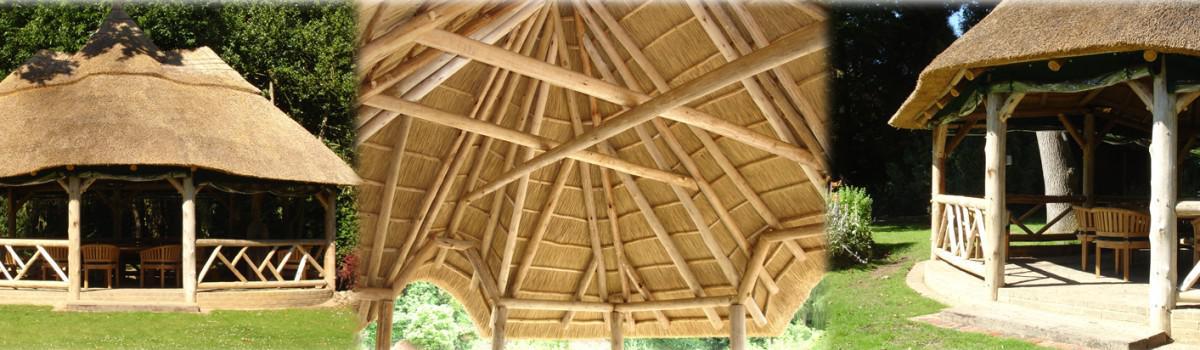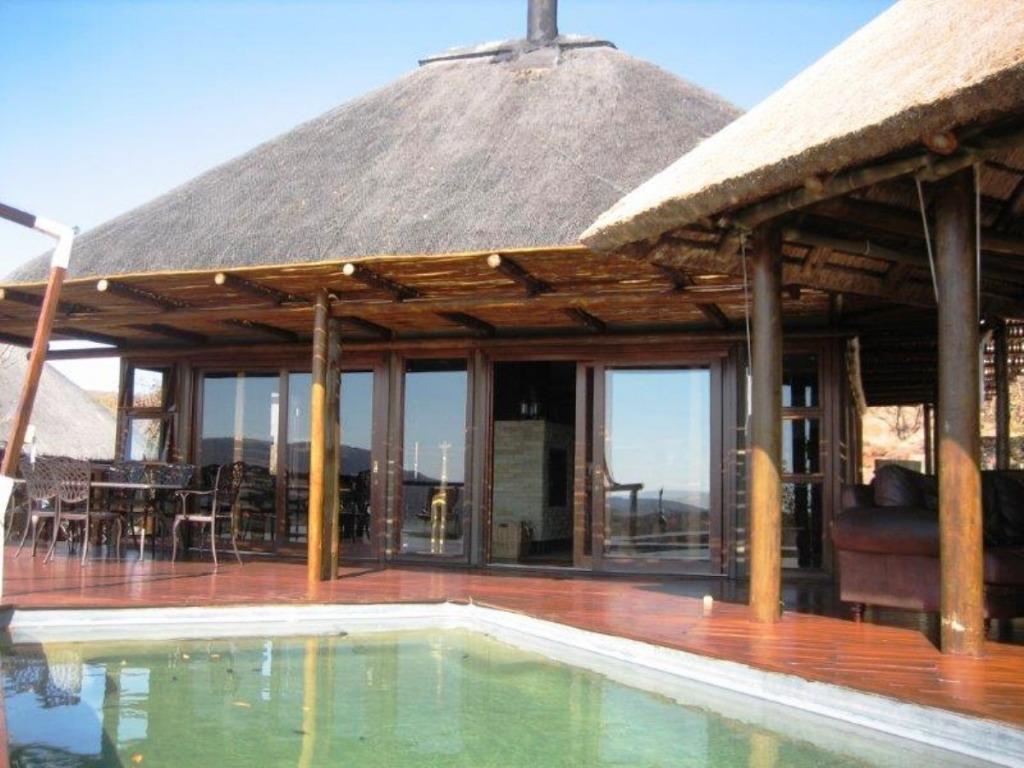The first image is the image on the left, the second image is the image on the right. Assess this claim about the two images: "In one of the images, you can see a man-made pool just in front of the dwelling.". Correct or not? Answer yes or no. Yes. The first image is the image on the left, the second image is the image on the right. Examine the images to the left and right. Is the description "There is a pool in one image and not the other." accurate? Answer yes or no. Yes. 